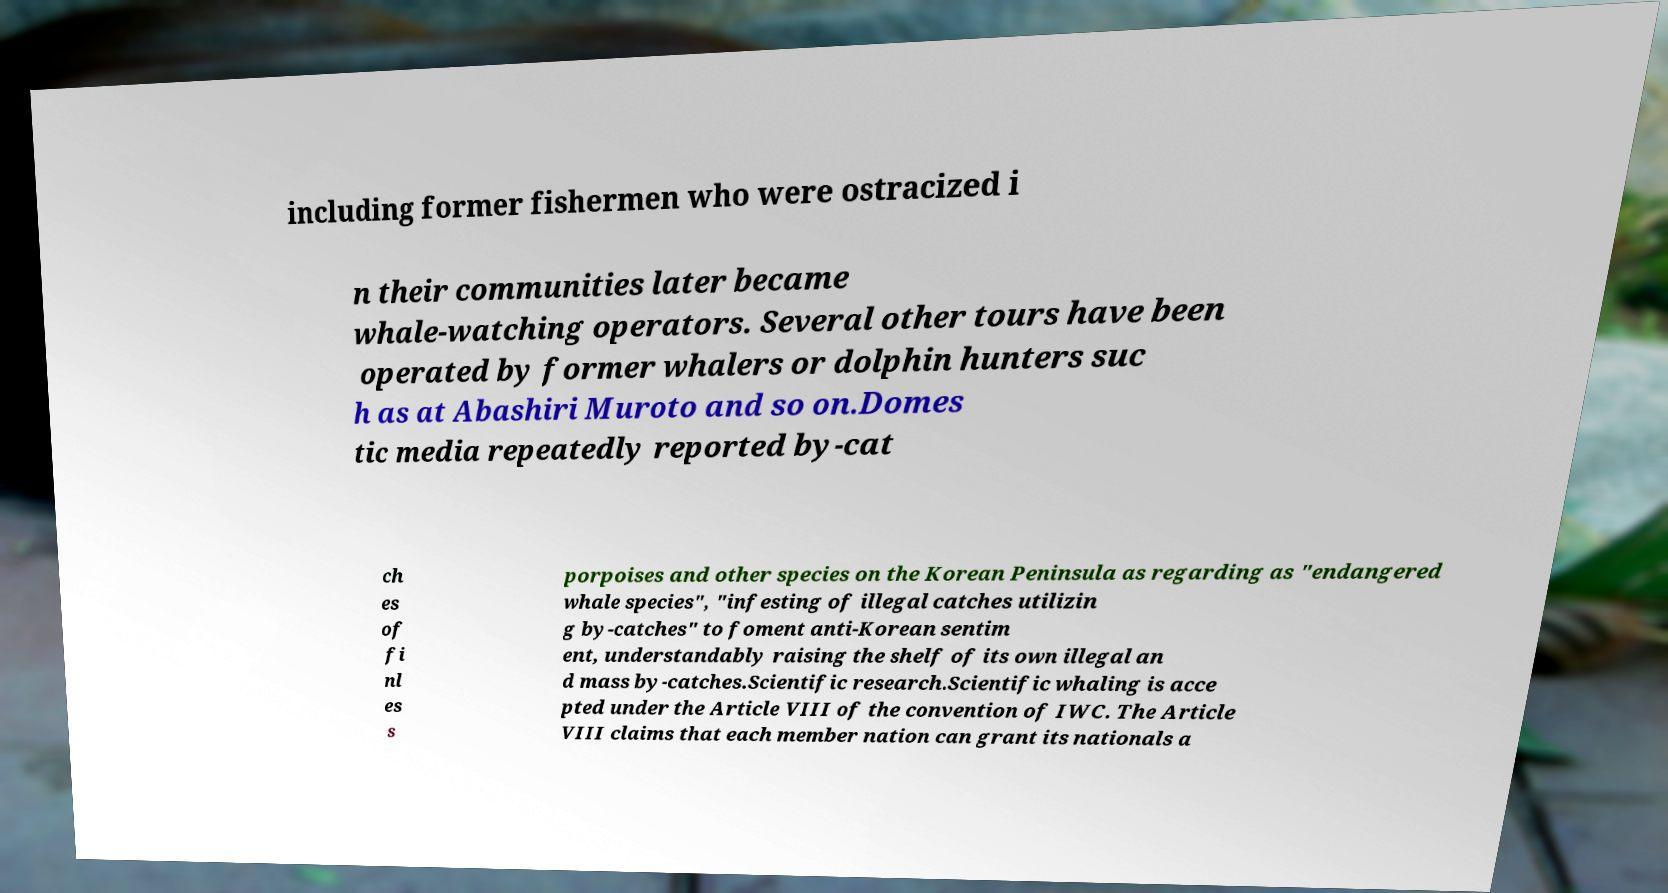There's text embedded in this image that I need extracted. Can you transcribe it verbatim? including former fishermen who were ostracized i n their communities later became whale-watching operators. Several other tours have been operated by former whalers or dolphin hunters suc h as at Abashiri Muroto and so on.Domes tic media repeatedly reported by-cat ch es of fi nl es s porpoises and other species on the Korean Peninsula as regarding as "endangered whale species", "infesting of illegal catches utilizin g by-catches" to foment anti-Korean sentim ent, understandably raising the shelf of its own illegal an d mass by-catches.Scientific research.Scientific whaling is acce pted under the Article VIII of the convention of IWC. The Article VIII claims that each member nation can grant its nationals a 